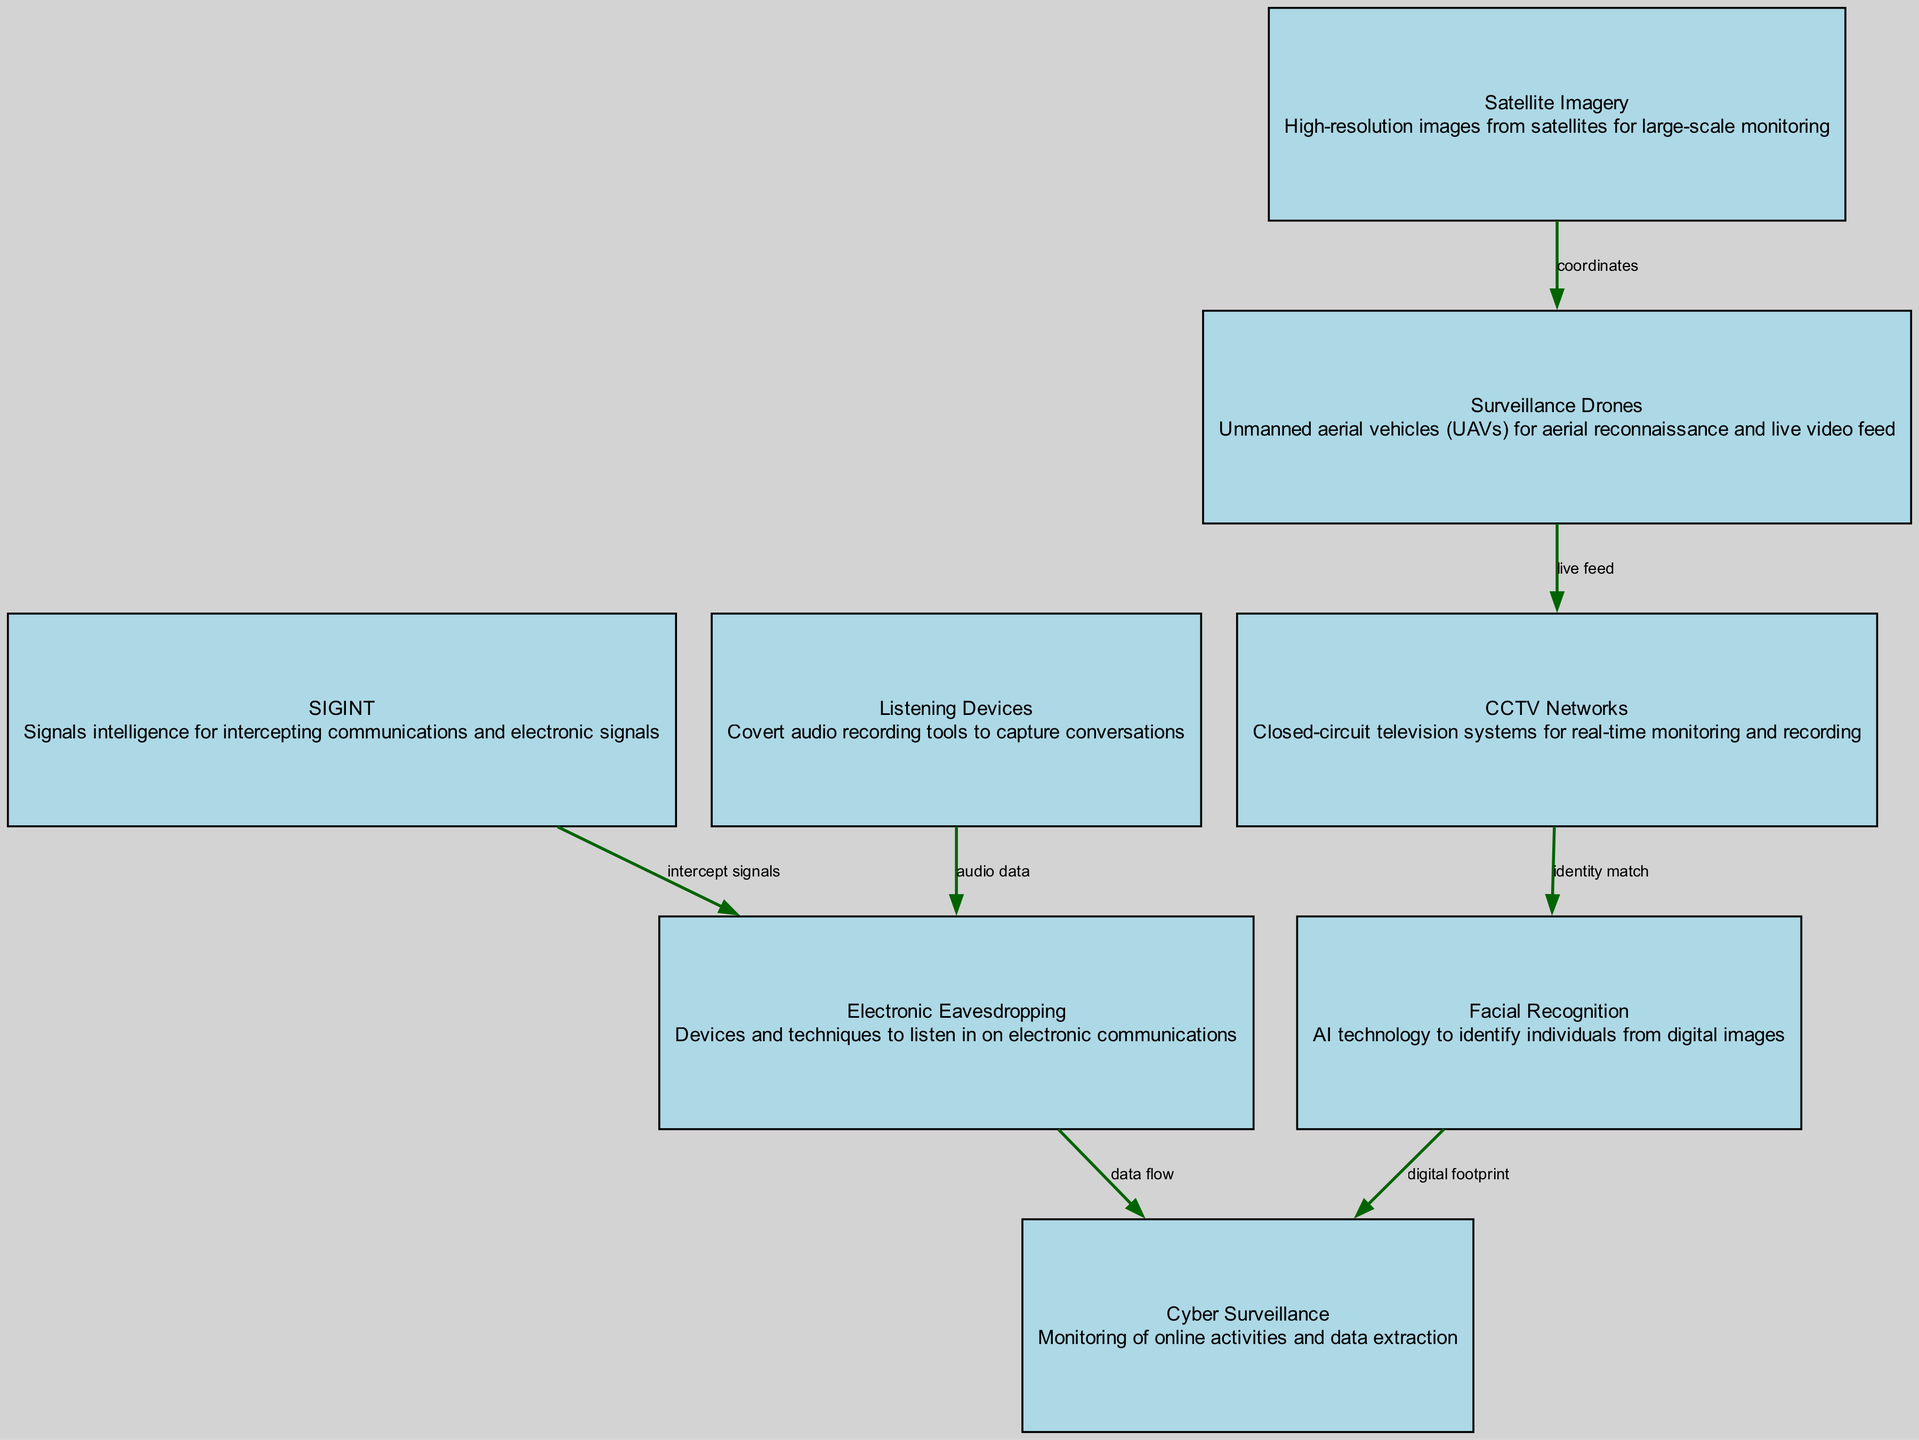What are the types of nodes in the diagram? The diagram contains eight nodes representing various surveillance technologies, including Surveillance Drones, CCTV Networks, SIGINT, Satellite Imagery, Listening Devices, Facial Recognition, Electronic Eavesdropping, and Cyber Surveillance.
Answer: Eight What is the relationship between Surveillance Drones and CCTV Networks? The edge connecting these two nodes indicates a "live feed," which signifies that surveillance drones can provide real-time video feed to CCTV networks for monitoring purposes.
Answer: Live feed How many edges are there in the diagram? By examining the edges listed, there are a total of six connections between the different nodes, indicating various relationships among the technologies used for surveillance.
Answer: Six What type of data does Listening Devices provide to Electronic Eavesdropping? The connection between Listening Devices and Electronic Eavesdropping is labeled "audio data," showing that Listening Devices capture audio that can be used or transmitted by eavesdropping techniques.
Answer: Audio data Which node is associated with high-resolution imagery? The node labeled "Satellite Imagery" specifically mentions high-resolution images used for large-scale monitoring, indicating its association with this capability.
Answer: Satellite Imagery How do Facial Recognition and Cyber Surveillance interact? The connection between Facial Recognition and Cyber Surveillance is described as a "digital footprint," suggesting that facial recognition technology aids in tracking online activities and identifying individuals through their digital presence.
Answer: Digital footprint What do the arrows represent in the diagram? The arrows in the diagram indicate the direction of flow or relationship between nodes, showing how different surveillance technologies can interact with one another and the type of data exchanged.
Answer: Direction of flow Which surveillance technology is linked to intercepting communications? The SIGINT node is responsible for intercepting communications and electronic signals, emphasizing its role in gathering intelligence through signal intelligence techniques.
Answer: SIGINT What does the edge from Cyber Surveillance to Electronic Eavesdropping signify? The edge labeled "data flow" between Cyber Surveillance and Electronic Eavesdropping indicates the transfer of collected data from online monitoring to eavesdropping tools, suggesting a sequence in intelligence-gathering activities.
Answer: Data flow 